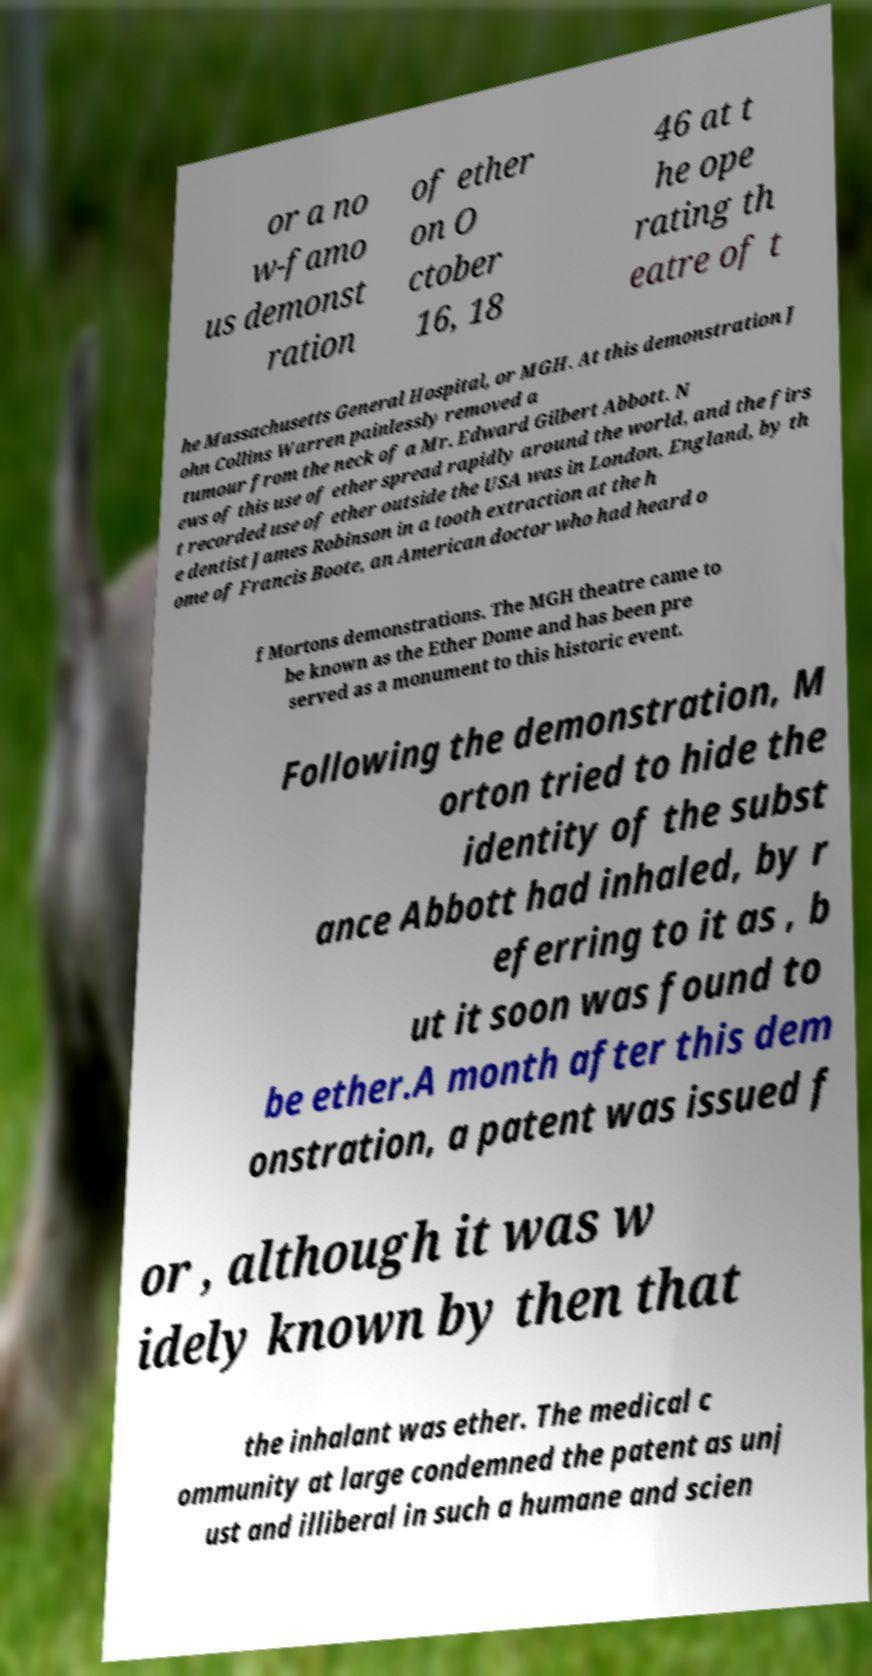Could you extract and type out the text from this image? or a no w-famo us demonst ration of ether on O ctober 16, 18 46 at t he ope rating th eatre of t he Massachusetts General Hospital, or MGH. At this demonstration J ohn Collins Warren painlessly removed a tumour from the neck of a Mr. Edward Gilbert Abbott. N ews of this use of ether spread rapidly around the world, and the firs t recorded use of ether outside the USA was in London, England, by th e dentist James Robinson in a tooth extraction at the h ome of Francis Boote, an American doctor who had heard o f Mortons demonstrations. The MGH theatre came to be known as the Ether Dome and has been pre served as a monument to this historic event. Following the demonstration, M orton tried to hide the identity of the subst ance Abbott had inhaled, by r eferring to it as , b ut it soon was found to be ether.A month after this dem onstration, a patent was issued f or , although it was w idely known by then that the inhalant was ether. The medical c ommunity at large condemned the patent as unj ust and illiberal in such a humane and scien 